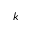Convert formula to latex. <formula><loc_0><loc_0><loc_500><loc_500>k</formula> 